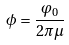<formula> <loc_0><loc_0><loc_500><loc_500>\phi = \frac { \varphi _ { 0 } } { 2 \pi \mu }</formula> 